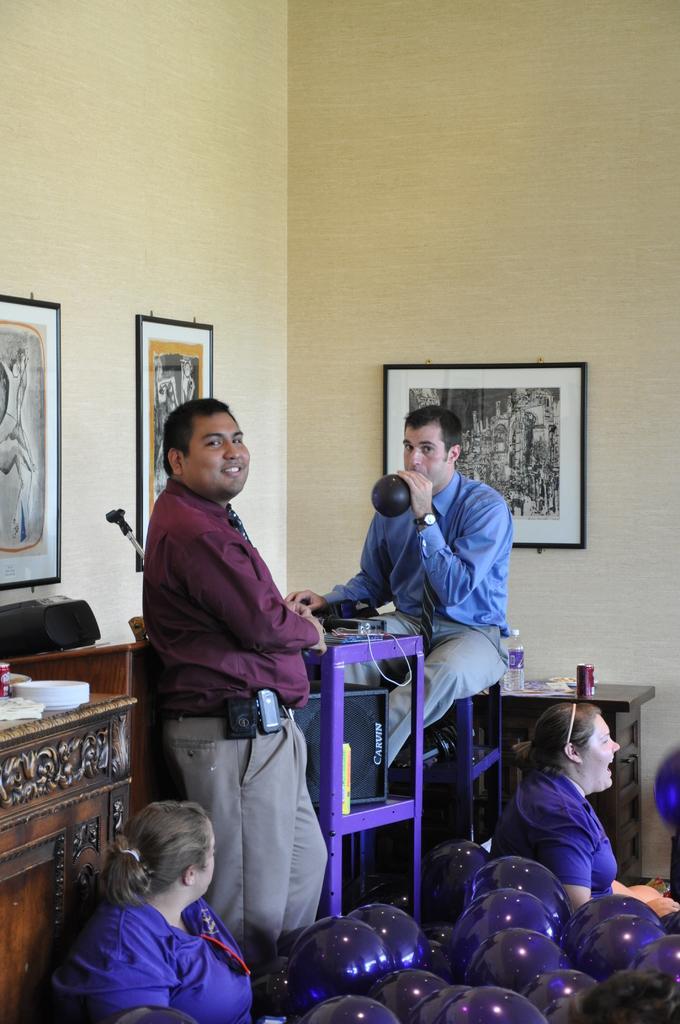Please provide a concise description of this image. In this image we can see a few people, one of them is sitting on the table, and blowing a balloon, there are some balloons, a bottle, and a tin on the table, we can see a stand, photo frames on the wall, speaker. 